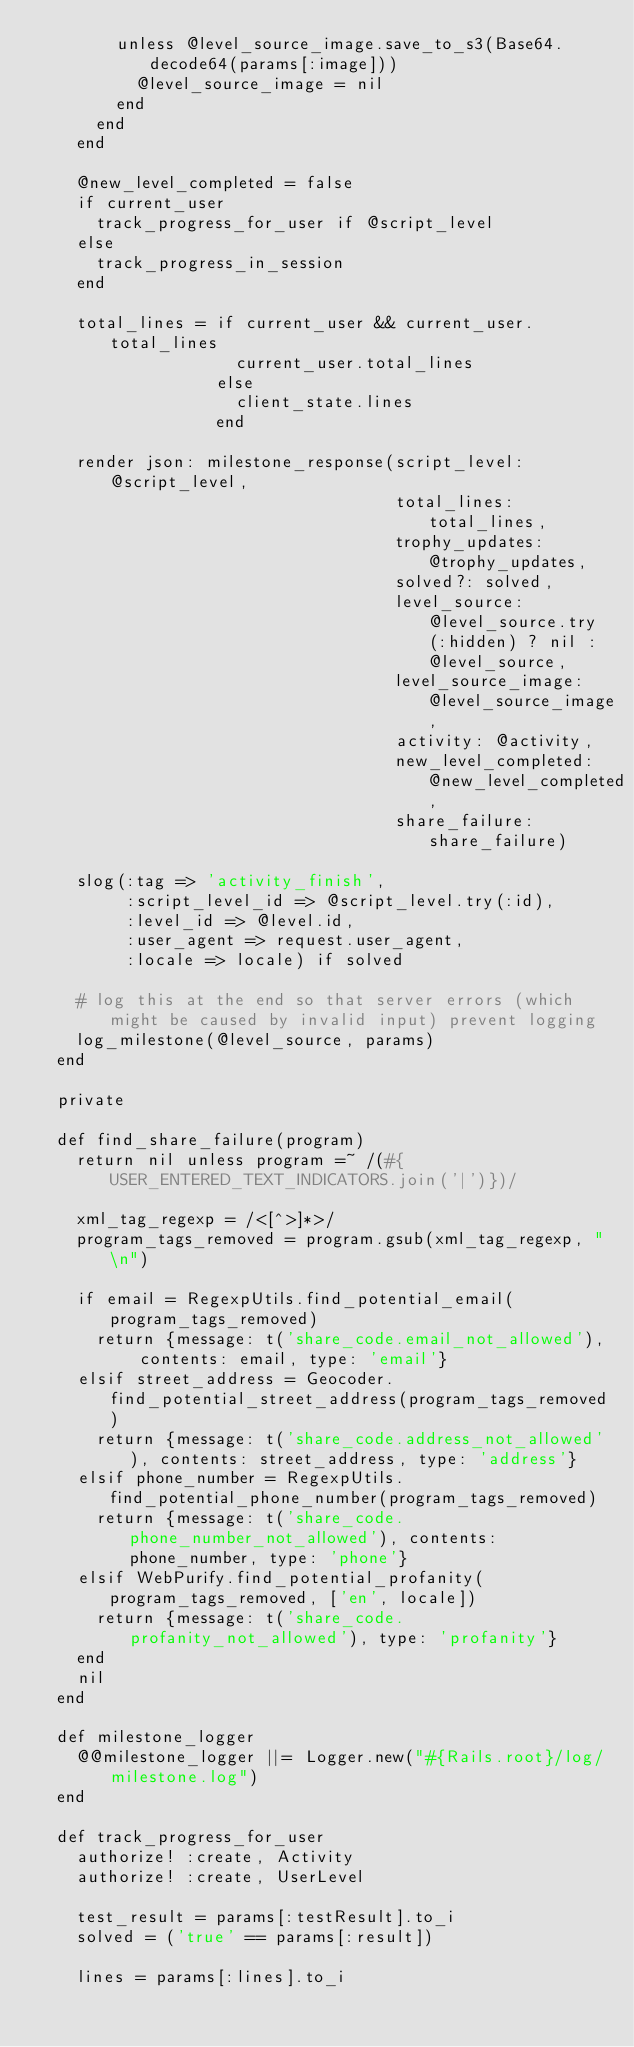<code> <loc_0><loc_0><loc_500><loc_500><_Ruby_>        unless @level_source_image.save_to_s3(Base64.decode64(params[:image]))
          @level_source_image = nil
        end
      end
    end

    @new_level_completed = false
    if current_user
      track_progress_for_user if @script_level
    else
      track_progress_in_session
    end

    total_lines = if current_user && current_user.total_lines
                    current_user.total_lines
                  else
                    client_state.lines
                  end

    render json: milestone_response(script_level: @script_level,
                                    total_lines: total_lines,
                                    trophy_updates: @trophy_updates,
                                    solved?: solved,
                                    level_source: @level_source.try(:hidden) ? nil : @level_source,
                                    level_source_image: @level_source_image,
                                    activity: @activity,
                                    new_level_completed: @new_level_completed,
                                    share_failure: share_failure)

    slog(:tag => 'activity_finish',
         :script_level_id => @script_level.try(:id),
         :level_id => @level.id,
         :user_agent => request.user_agent,
         :locale => locale) if solved

    # log this at the end so that server errors (which might be caused by invalid input) prevent logging
    log_milestone(@level_source, params)
  end

  private

  def find_share_failure(program)
    return nil unless program =~ /(#{USER_ENTERED_TEXT_INDICATORS.join('|')})/

    xml_tag_regexp = /<[^>]*>/
    program_tags_removed = program.gsub(xml_tag_regexp, "\n")

    if email = RegexpUtils.find_potential_email(program_tags_removed)
      return {message: t('share_code.email_not_allowed'), contents: email, type: 'email'}
    elsif street_address = Geocoder.find_potential_street_address(program_tags_removed)
      return {message: t('share_code.address_not_allowed'), contents: street_address, type: 'address'}
    elsif phone_number = RegexpUtils.find_potential_phone_number(program_tags_removed)
      return {message: t('share_code.phone_number_not_allowed'), contents: phone_number, type: 'phone'}
    elsif WebPurify.find_potential_profanity(program_tags_removed, ['en', locale])
      return {message: t('share_code.profanity_not_allowed'), type: 'profanity'}
    end
    nil
  end

  def milestone_logger
    @@milestone_logger ||= Logger.new("#{Rails.root}/log/milestone.log")
  end

  def track_progress_for_user
    authorize! :create, Activity
    authorize! :create, UserLevel

    test_result = params[:testResult].to_i
    solved = ('true' == params[:result])

    lines = params[:lines].to_i
</code> 